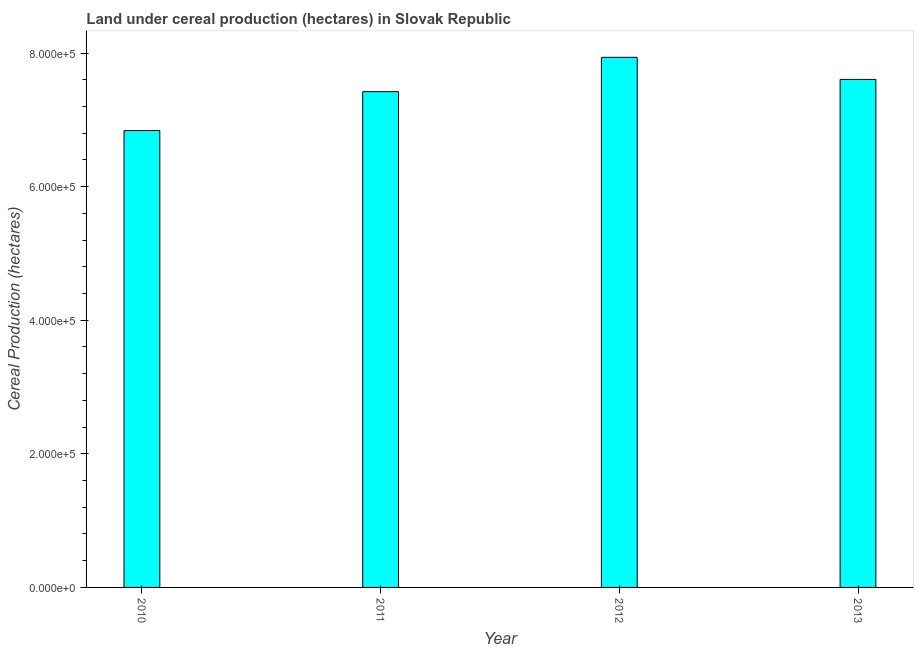Does the graph contain any zero values?
Provide a succinct answer. No. Does the graph contain grids?
Provide a succinct answer. No. What is the title of the graph?
Your answer should be very brief. Land under cereal production (hectares) in Slovak Republic. What is the label or title of the Y-axis?
Offer a terse response. Cereal Production (hectares). What is the land under cereal production in 2011?
Your response must be concise. 7.42e+05. Across all years, what is the maximum land under cereal production?
Offer a terse response. 7.94e+05. Across all years, what is the minimum land under cereal production?
Provide a short and direct response. 6.84e+05. In which year was the land under cereal production minimum?
Your answer should be compact. 2010. What is the sum of the land under cereal production?
Provide a short and direct response. 2.98e+06. What is the difference between the land under cereal production in 2012 and 2013?
Offer a terse response. 3.30e+04. What is the average land under cereal production per year?
Keep it short and to the point. 7.45e+05. What is the median land under cereal production?
Your answer should be very brief. 7.51e+05. In how many years, is the land under cereal production greater than 680000 hectares?
Your answer should be very brief. 4. Do a majority of the years between 2010 and 2012 (inclusive) have land under cereal production greater than 40000 hectares?
Give a very brief answer. Yes. What is the ratio of the land under cereal production in 2012 to that in 2013?
Offer a terse response. 1.04. Is the difference between the land under cereal production in 2010 and 2011 greater than the difference between any two years?
Offer a very short reply. No. What is the difference between the highest and the second highest land under cereal production?
Your response must be concise. 3.30e+04. Is the sum of the land under cereal production in 2012 and 2013 greater than the maximum land under cereal production across all years?
Provide a short and direct response. Yes. What is the difference between the highest and the lowest land under cereal production?
Your answer should be compact. 1.10e+05. Are all the bars in the graph horizontal?
Provide a short and direct response. No. How many years are there in the graph?
Make the answer very short. 4. What is the Cereal Production (hectares) in 2010?
Your answer should be compact. 6.84e+05. What is the Cereal Production (hectares) in 2011?
Your response must be concise. 7.42e+05. What is the Cereal Production (hectares) in 2012?
Provide a short and direct response. 7.94e+05. What is the Cereal Production (hectares) of 2013?
Your answer should be compact. 7.61e+05. What is the difference between the Cereal Production (hectares) in 2010 and 2011?
Make the answer very short. -5.83e+04. What is the difference between the Cereal Production (hectares) in 2010 and 2012?
Your response must be concise. -1.10e+05. What is the difference between the Cereal Production (hectares) in 2010 and 2013?
Keep it short and to the point. -7.66e+04. What is the difference between the Cereal Production (hectares) in 2011 and 2012?
Give a very brief answer. -5.14e+04. What is the difference between the Cereal Production (hectares) in 2011 and 2013?
Make the answer very short. -1.83e+04. What is the difference between the Cereal Production (hectares) in 2012 and 2013?
Offer a terse response. 3.30e+04. What is the ratio of the Cereal Production (hectares) in 2010 to that in 2011?
Offer a very short reply. 0.92. What is the ratio of the Cereal Production (hectares) in 2010 to that in 2012?
Provide a short and direct response. 0.86. What is the ratio of the Cereal Production (hectares) in 2010 to that in 2013?
Your answer should be compact. 0.9. What is the ratio of the Cereal Production (hectares) in 2011 to that in 2012?
Give a very brief answer. 0.94. What is the ratio of the Cereal Production (hectares) in 2012 to that in 2013?
Make the answer very short. 1.04. 